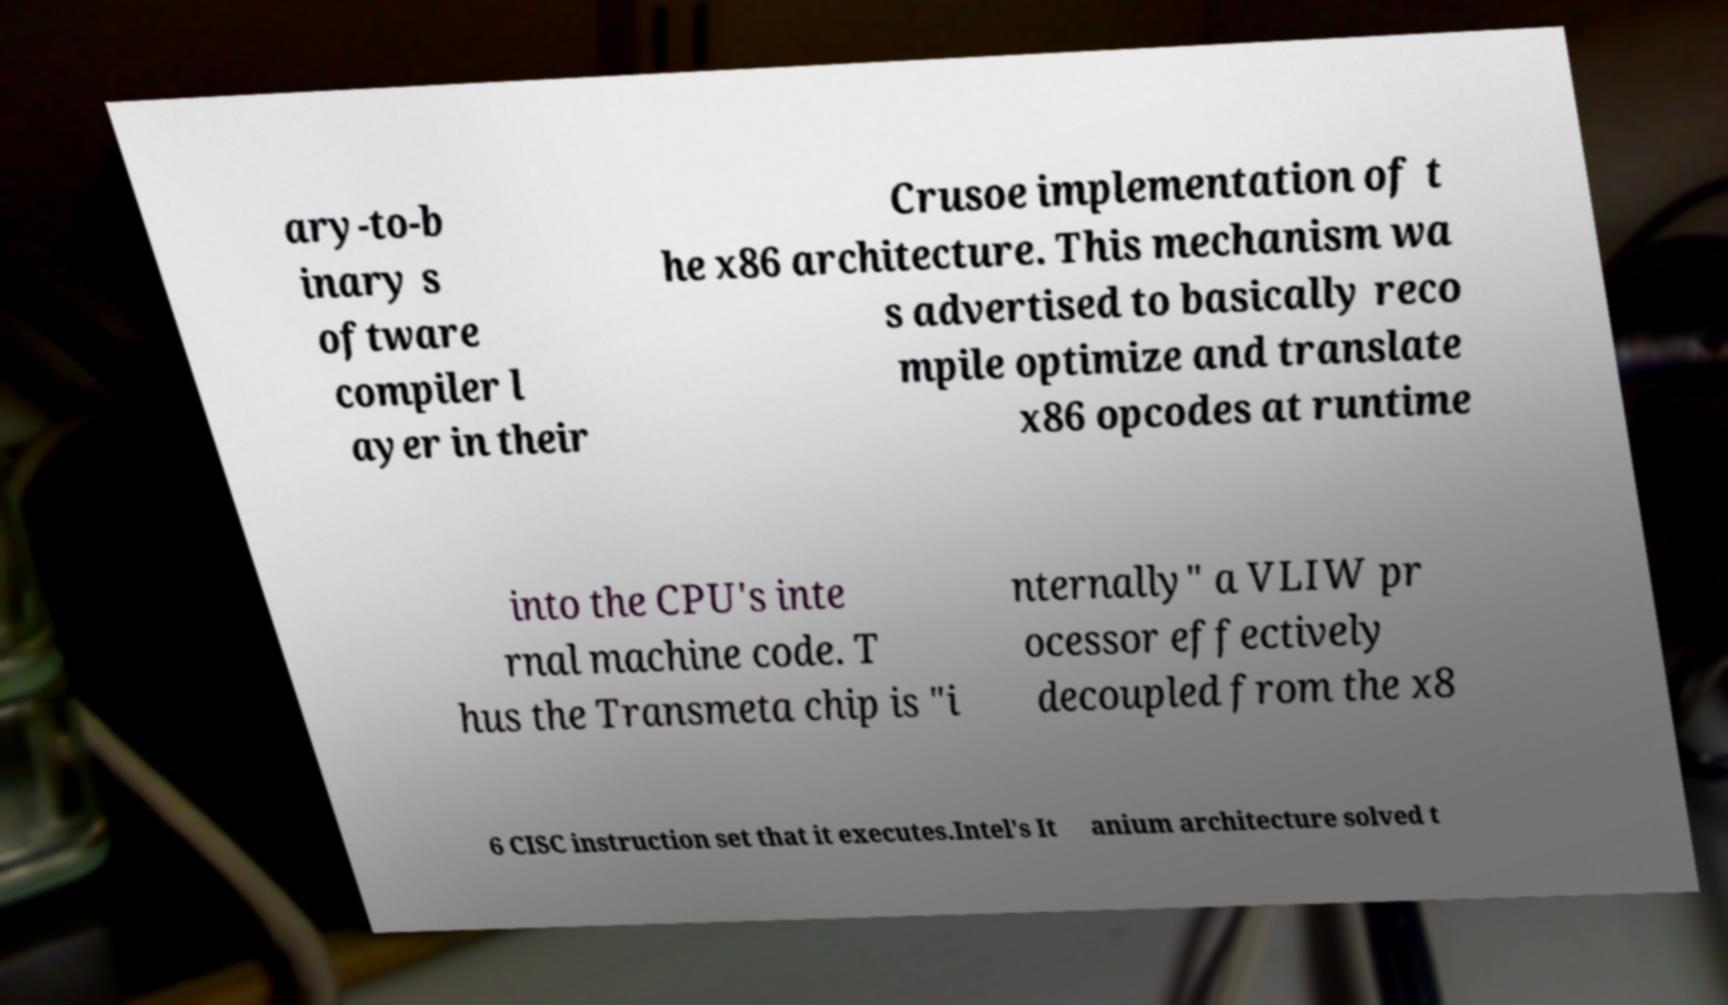There's text embedded in this image that I need extracted. Can you transcribe it verbatim? ary-to-b inary s oftware compiler l ayer in their Crusoe implementation of t he x86 architecture. This mechanism wa s advertised to basically reco mpile optimize and translate x86 opcodes at runtime into the CPU's inte rnal machine code. T hus the Transmeta chip is "i nternally" a VLIW pr ocessor effectively decoupled from the x8 6 CISC instruction set that it executes.Intel's It anium architecture solved t 